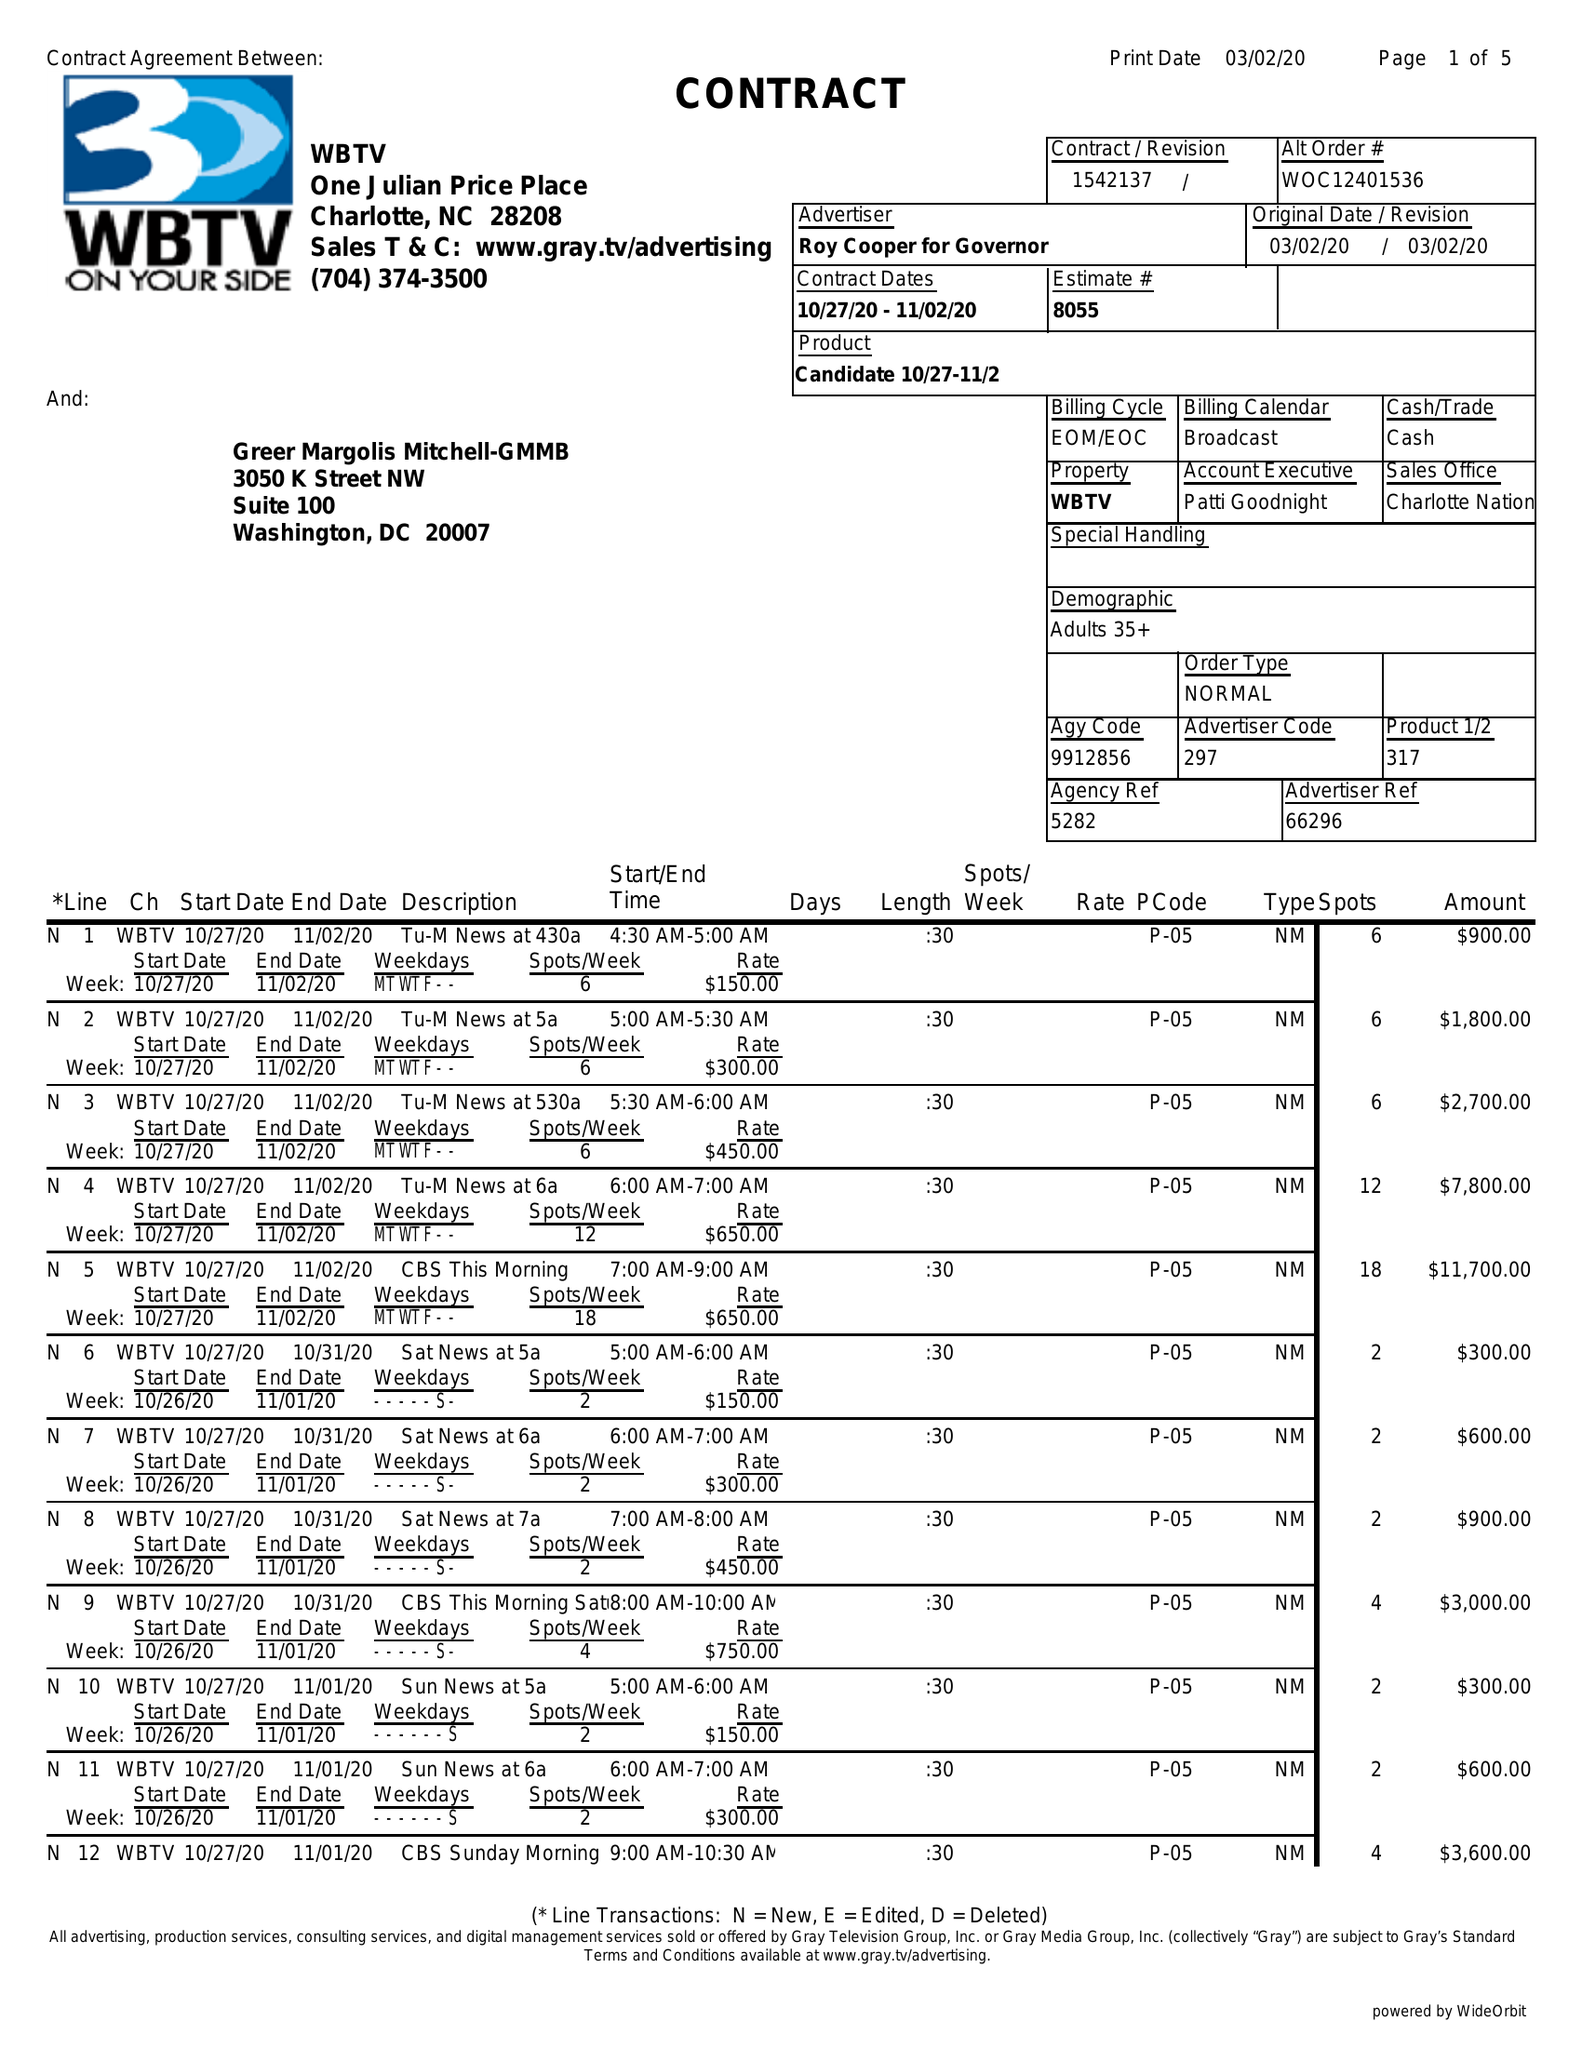What is the value for the advertiser?
Answer the question using a single word or phrase. ROY COOPER FOR GOVERNOR 